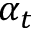Convert formula to latex. <formula><loc_0><loc_0><loc_500><loc_500>\alpha _ { t }</formula> 